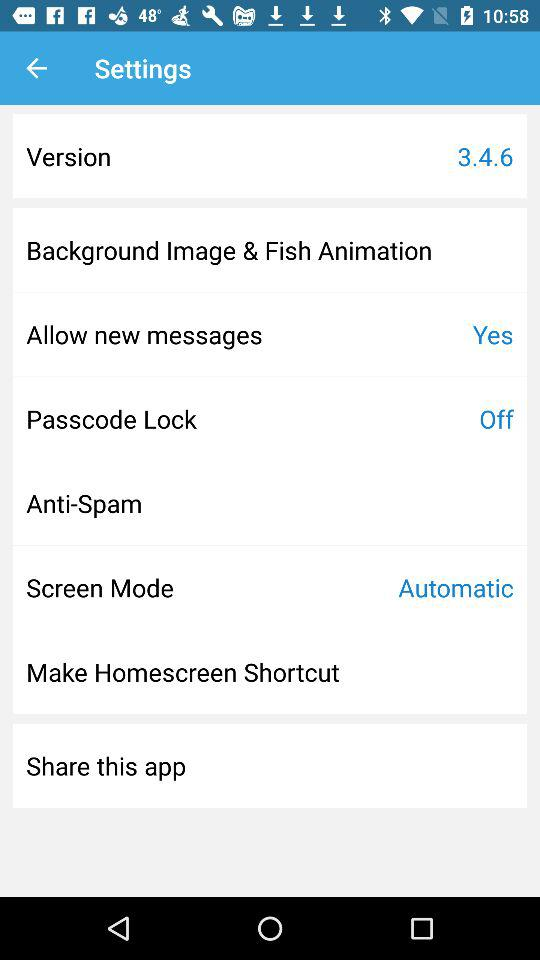What is the status of the passcode lock? The status is "off". 